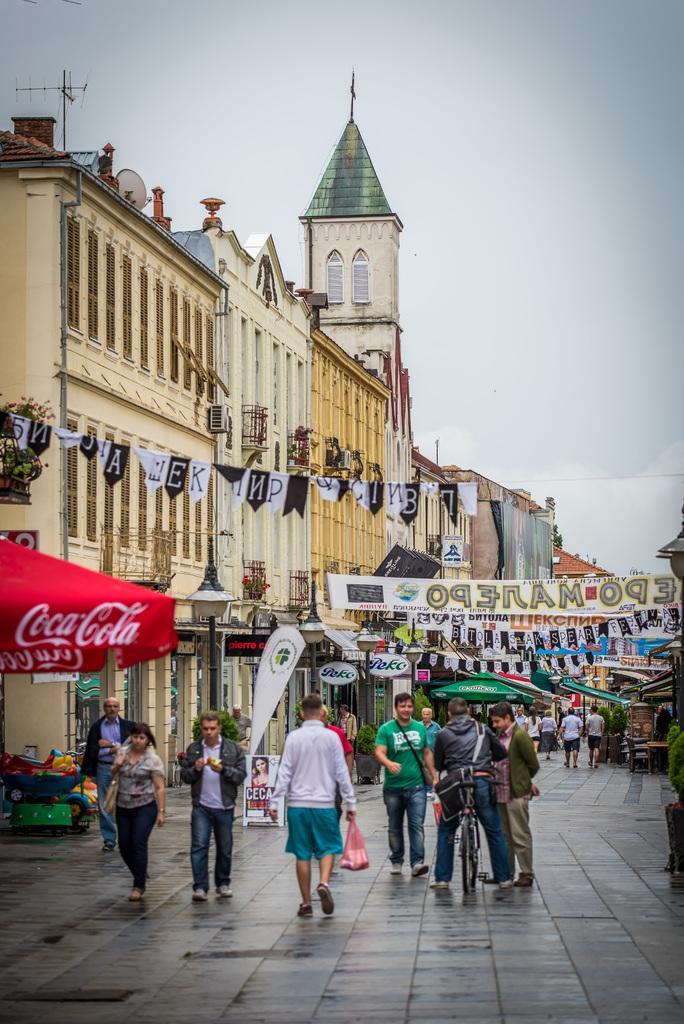Can you describe this image briefly? In this image I can see some people. On the left side I can see the buildings. In the background, I can see the clouds in the sky. 